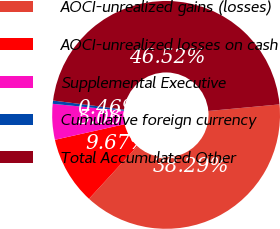<chart> <loc_0><loc_0><loc_500><loc_500><pie_chart><fcel>AOCI-unrealized gains (losses)<fcel>AOCI-unrealized losses on cash<fcel>Supplemental Executive<fcel>Cumulative foreign currency<fcel>Total Accumulated Other<nl><fcel>38.29%<fcel>9.67%<fcel>5.06%<fcel>0.46%<fcel>46.52%<nl></chart> 